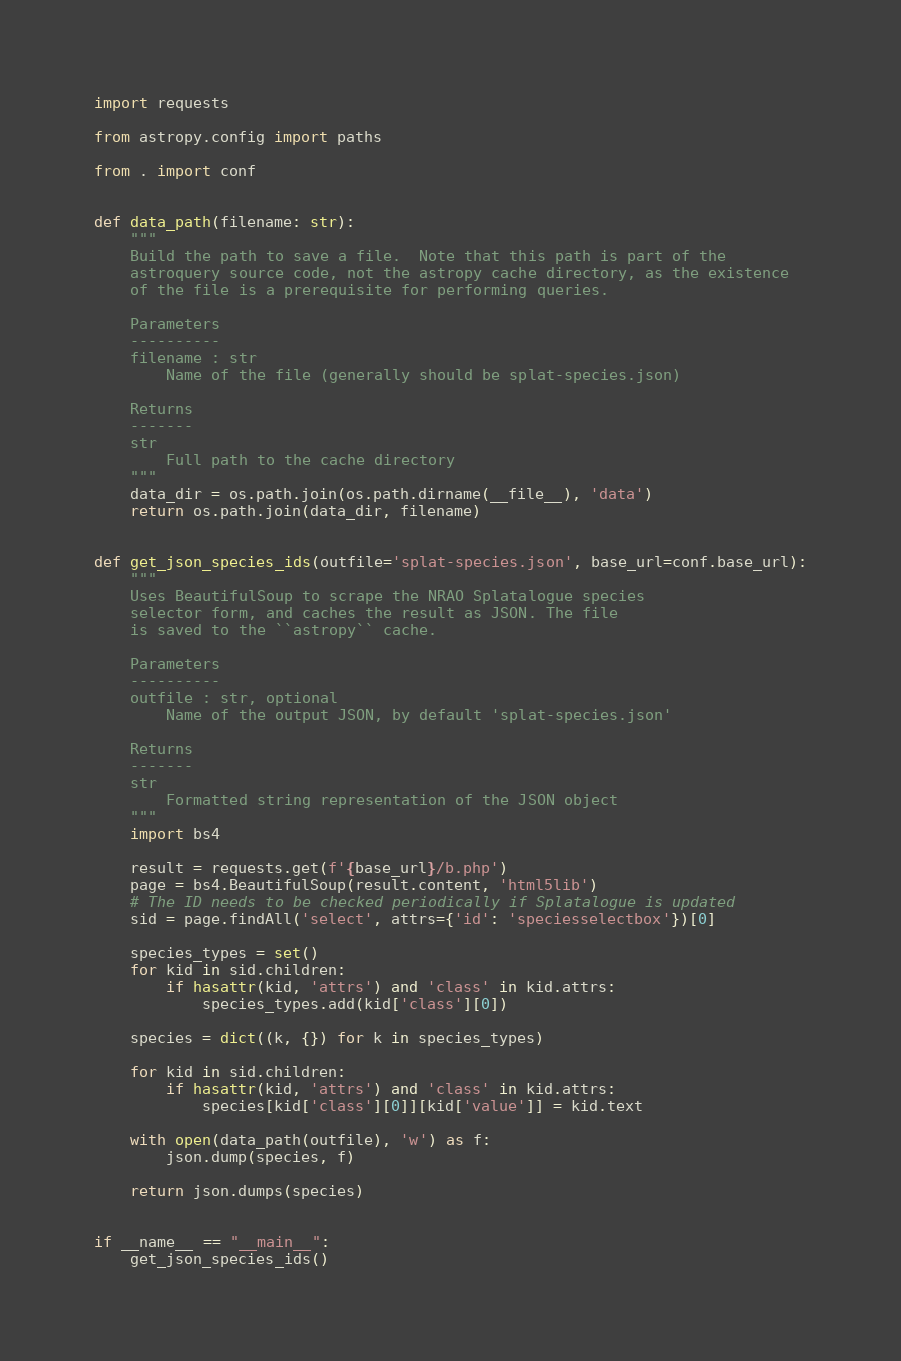Convert code to text. <code><loc_0><loc_0><loc_500><loc_500><_Python_>import requests

from astropy.config import paths

from . import conf


def data_path(filename: str):
    """
    Build the path to save a file.  Note that this path is part of the
    astroquery source code, not the astropy cache directory, as the existence
    of the file is a prerequisite for performing queries.

    Parameters
    ----------
    filename : str
        Name of the file (generally should be splat-species.json)

    Returns
    -------
    str
        Full path to the cache directory
    """
    data_dir = os.path.join(os.path.dirname(__file__), 'data')
    return os.path.join(data_dir, filename)


def get_json_species_ids(outfile='splat-species.json', base_url=conf.base_url):
    """
    Uses BeautifulSoup to scrape the NRAO Splatalogue species
    selector form, and caches the result as JSON. The file
    is saved to the ``astropy`` cache.

    Parameters
    ----------
    outfile : str, optional
        Name of the output JSON, by default 'splat-species.json'

    Returns
    -------
    str
        Formatted string representation of the JSON object
    """
    import bs4

    result = requests.get(f'{base_url}/b.php')
    page = bs4.BeautifulSoup(result.content, 'html5lib')
    # The ID needs to be checked periodically if Splatalogue is updated
    sid = page.findAll('select', attrs={'id': 'speciesselectbox'})[0]

    species_types = set()
    for kid in sid.children:
        if hasattr(kid, 'attrs') and 'class' in kid.attrs:
            species_types.add(kid['class'][0])

    species = dict((k, {}) for k in species_types)

    for kid in sid.children:
        if hasattr(kid, 'attrs') and 'class' in kid.attrs:
            species[kid['class'][0]][kid['value']] = kid.text

    with open(data_path(outfile), 'w') as f:
        json.dump(species, f)

    return json.dumps(species)


if __name__ == "__main__":
    get_json_species_ids()
</code> 